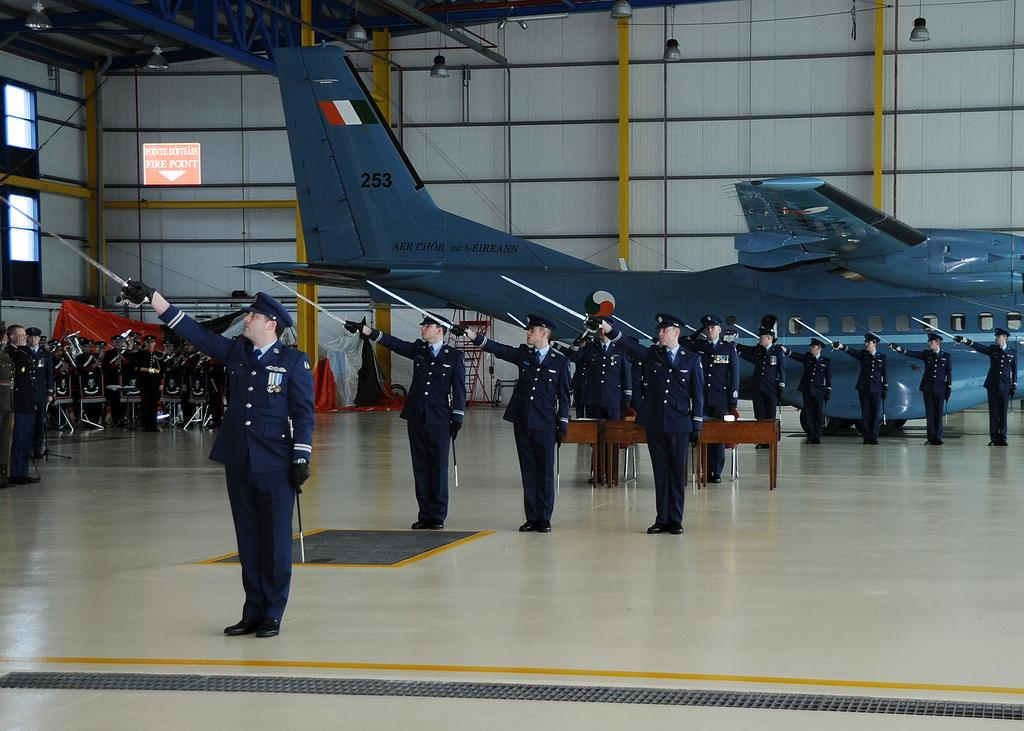<image>
Relay a brief, clear account of the picture shown. people in military garb salute under a sign reading Pointe Doiteain Fire Point 